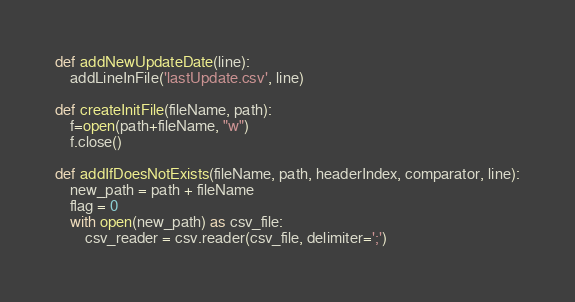Convert code to text. <code><loc_0><loc_0><loc_500><loc_500><_Python_>def addNewUpdateDate(line):
    addLineInFile('lastUpdate.csv', line)

def createInitFile(fileName, path):
    f=open(path+fileName, "w")
    f.close()

def addIfDoesNotExists(fileName, path, headerIndex, comparator, line):
    new_path = path + fileName
    flag = 0
    with open(new_path) as csv_file:
        csv_reader = csv.reader(csv_file, delimiter=';')</code> 